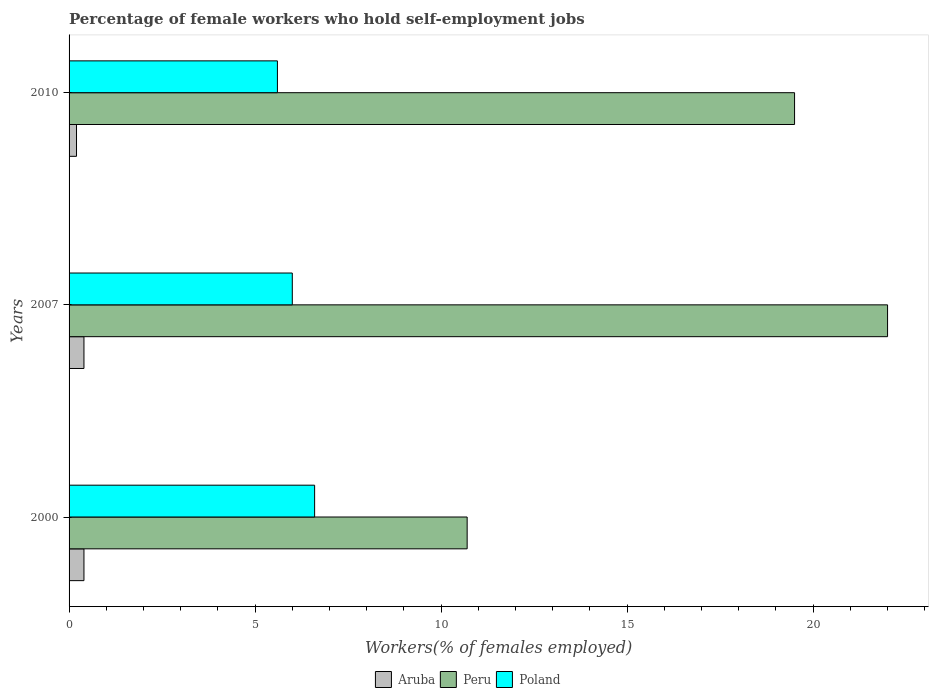Are the number of bars on each tick of the Y-axis equal?
Ensure brevity in your answer.  Yes. How many bars are there on the 2nd tick from the bottom?
Your answer should be very brief. 3. What is the label of the 1st group of bars from the top?
Keep it short and to the point. 2010. What is the percentage of self-employed female workers in Aruba in 2010?
Provide a succinct answer. 0.2. Across all years, what is the maximum percentage of self-employed female workers in Aruba?
Keep it short and to the point. 0.4. Across all years, what is the minimum percentage of self-employed female workers in Aruba?
Your answer should be compact. 0.2. What is the total percentage of self-employed female workers in Aruba in the graph?
Offer a very short reply. 1. What is the difference between the percentage of self-employed female workers in Aruba in 2007 and that in 2010?
Your response must be concise. 0.2. What is the difference between the percentage of self-employed female workers in Peru in 2000 and the percentage of self-employed female workers in Poland in 2007?
Ensure brevity in your answer.  4.7. What is the average percentage of self-employed female workers in Aruba per year?
Ensure brevity in your answer.  0.33. In the year 2000, what is the difference between the percentage of self-employed female workers in Aruba and percentage of self-employed female workers in Poland?
Your answer should be very brief. -6.2. What is the ratio of the percentage of self-employed female workers in Poland in 2007 to that in 2010?
Ensure brevity in your answer.  1.07. Is the difference between the percentage of self-employed female workers in Aruba in 2000 and 2010 greater than the difference between the percentage of self-employed female workers in Poland in 2000 and 2010?
Offer a terse response. No. Is the sum of the percentage of self-employed female workers in Peru in 2000 and 2010 greater than the maximum percentage of self-employed female workers in Aruba across all years?
Provide a short and direct response. Yes. What does the 1st bar from the bottom in 2007 represents?
Keep it short and to the point. Aruba. How many bars are there?
Keep it short and to the point. 9. How many years are there in the graph?
Your answer should be very brief. 3. What is the difference between two consecutive major ticks on the X-axis?
Make the answer very short. 5. Are the values on the major ticks of X-axis written in scientific E-notation?
Keep it short and to the point. No. How many legend labels are there?
Offer a terse response. 3. What is the title of the graph?
Keep it short and to the point. Percentage of female workers who hold self-employment jobs. Does "Sudan" appear as one of the legend labels in the graph?
Your response must be concise. No. What is the label or title of the X-axis?
Provide a succinct answer. Workers(% of females employed). What is the Workers(% of females employed) in Aruba in 2000?
Ensure brevity in your answer.  0.4. What is the Workers(% of females employed) in Peru in 2000?
Offer a terse response. 10.7. What is the Workers(% of females employed) in Poland in 2000?
Offer a very short reply. 6.6. What is the Workers(% of females employed) of Aruba in 2007?
Your answer should be compact. 0.4. What is the Workers(% of females employed) in Poland in 2007?
Make the answer very short. 6. What is the Workers(% of females employed) of Aruba in 2010?
Provide a succinct answer. 0.2. What is the Workers(% of females employed) in Poland in 2010?
Keep it short and to the point. 5.6. Across all years, what is the maximum Workers(% of females employed) of Aruba?
Your answer should be very brief. 0.4. Across all years, what is the maximum Workers(% of females employed) in Poland?
Offer a terse response. 6.6. Across all years, what is the minimum Workers(% of females employed) in Aruba?
Provide a succinct answer. 0.2. Across all years, what is the minimum Workers(% of females employed) in Peru?
Make the answer very short. 10.7. Across all years, what is the minimum Workers(% of females employed) of Poland?
Your answer should be very brief. 5.6. What is the total Workers(% of females employed) in Peru in the graph?
Provide a succinct answer. 52.2. What is the difference between the Workers(% of females employed) in Peru in 2000 and that in 2007?
Ensure brevity in your answer.  -11.3. What is the difference between the Workers(% of females employed) of Aruba in 2000 and that in 2010?
Offer a very short reply. 0.2. What is the difference between the Workers(% of females employed) of Peru in 2000 and that in 2010?
Keep it short and to the point. -8.8. What is the difference between the Workers(% of females employed) of Aruba in 2007 and that in 2010?
Provide a succinct answer. 0.2. What is the difference between the Workers(% of females employed) in Peru in 2007 and that in 2010?
Ensure brevity in your answer.  2.5. What is the difference between the Workers(% of females employed) of Aruba in 2000 and the Workers(% of females employed) of Peru in 2007?
Keep it short and to the point. -21.6. What is the difference between the Workers(% of females employed) in Aruba in 2000 and the Workers(% of females employed) in Poland in 2007?
Offer a very short reply. -5.6. What is the difference between the Workers(% of females employed) of Peru in 2000 and the Workers(% of females employed) of Poland in 2007?
Your answer should be compact. 4.7. What is the difference between the Workers(% of females employed) of Aruba in 2000 and the Workers(% of females employed) of Peru in 2010?
Provide a succinct answer. -19.1. What is the difference between the Workers(% of females employed) in Peru in 2000 and the Workers(% of females employed) in Poland in 2010?
Keep it short and to the point. 5.1. What is the difference between the Workers(% of females employed) of Aruba in 2007 and the Workers(% of females employed) of Peru in 2010?
Offer a terse response. -19.1. What is the difference between the Workers(% of females employed) of Aruba in 2007 and the Workers(% of females employed) of Poland in 2010?
Offer a very short reply. -5.2. What is the average Workers(% of females employed) in Peru per year?
Your response must be concise. 17.4. What is the average Workers(% of females employed) of Poland per year?
Provide a short and direct response. 6.07. In the year 2007, what is the difference between the Workers(% of females employed) of Aruba and Workers(% of females employed) of Peru?
Provide a succinct answer. -21.6. In the year 2007, what is the difference between the Workers(% of females employed) in Aruba and Workers(% of females employed) in Poland?
Give a very brief answer. -5.6. In the year 2007, what is the difference between the Workers(% of females employed) in Peru and Workers(% of females employed) in Poland?
Provide a succinct answer. 16. In the year 2010, what is the difference between the Workers(% of females employed) in Aruba and Workers(% of females employed) in Peru?
Your answer should be very brief. -19.3. In the year 2010, what is the difference between the Workers(% of females employed) in Peru and Workers(% of females employed) in Poland?
Your response must be concise. 13.9. What is the ratio of the Workers(% of females employed) in Peru in 2000 to that in 2007?
Provide a short and direct response. 0.49. What is the ratio of the Workers(% of females employed) in Peru in 2000 to that in 2010?
Make the answer very short. 0.55. What is the ratio of the Workers(% of females employed) of Poland in 2000 to that in 2010?
Your answer should be very brief. 1.18. What is the ratio of the Workers(% of females employed) of Peru in 2007 to that in 2010?
Make the answer very short. 1.13. What is the ratio of the Workers(% of females employed) in Poland in 2007 to that in 2010?
Your answer should be very brief. 1.07. What is the difference between the highest and the second highest Workers(% of females employed) in Peru?
Offer a terse response. 2.5. What is the difference between the highest and the lowest Workers(% of females employed) in Peru?
Give a very brief answer. 11.3. 